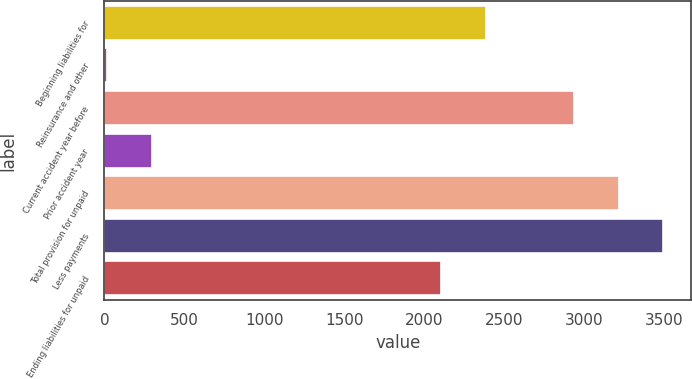Convert chart. <chart><loc_0><loc_0><loc_500><loc_500><bar_chart><fcel>Beginning liabilities for<fcel>Reinsurance and other<fcel>Current accident year before<fcel>Prior accident year<fcel>Total provision for unpaid<fcel>Less payments<fcel>Ending liabilities for unpaid<nl><fcel>2382<fcel>18<fcel>2938<fcel>296<fcel>3216<fcel>3494<fcel>2104<nl></chart> 